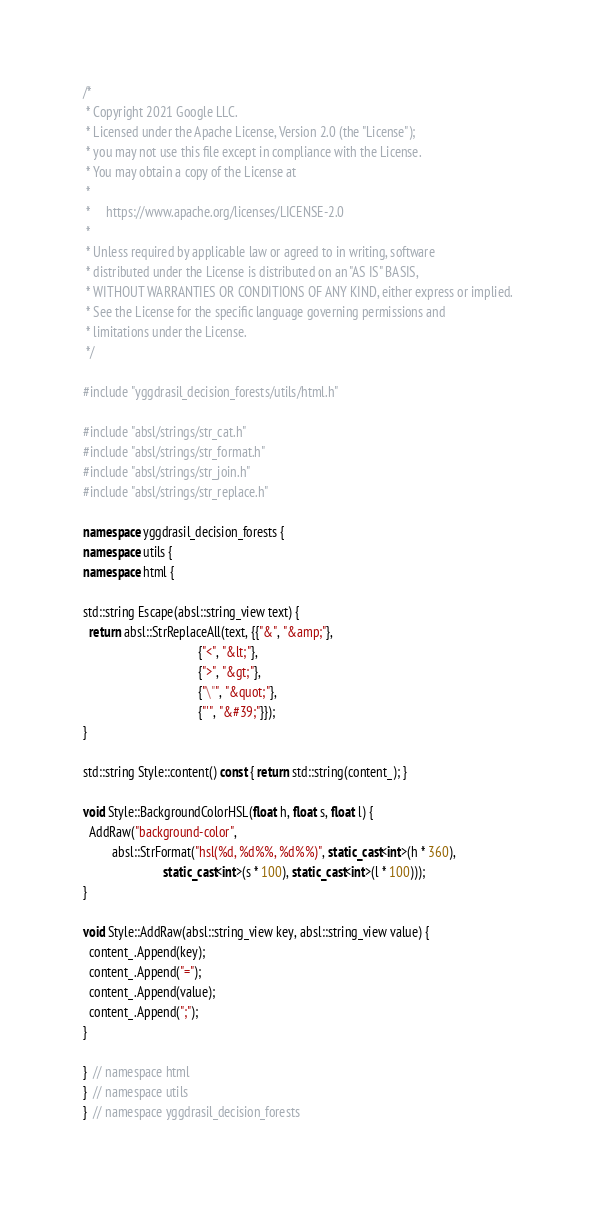Convert code to text. <code><loc_0><loc_0><loc_500><loc_500><_C++_>/*
 * Copyright 2021 Google LLC.
 * Licensed under the Apache License, Version 2.0 (the "License");
 * you may not use this file except in compliance with the License.
 * You may obtain a copy of the License at
 *
 *     https://www.apache.org/licenses/LICENSE-2.0
 *
 * Unless required by applicable law or agreed to in writing, software
 * distributed under the License is distributed on an "AS IS" BASIS,
 * WITHOUT WARRANTIES OR CONDITIONS OF ANY KIND, either express or implied.
 * See the License for the specific language governing permissions and
 * limitations under the License.
 */

#include "yggdrasil_decision_forests/utils/html.h"

#include "absl/strings/str_cat.h"
#include "absl/strings/str_format.h"
#include "absl/strings/str_join.h"
#include "absl/strings/str_replace.h"

namespace yggdrasil_decision_forests {
namespace utils {
namespace html {

std::string Escape(absl::string_view text) {
  return absl::StrReplaceAll(text, {{"&", "&amp;"},
                                    {"<", "&lt;"},
                                    {">", "&gt;"},
                                    {"\"", "&quot;"},
                                    {"'", "&#39;"}});
}

std::string Style::content() const { return std::string(content_); }

void Style::BackgroundColorHSL(float h, float s, float l) {
  AddRaw("background-color",
         absl::StrFormat("hsl(%d, %d%%, %d%%)", static_cast<int>(h * 360),
                         static_cast<int>(s * 100), static_cast<int>(l * 100)));
}

void Style::AddRaw(absl::string_view key, absl::string_view value) {
  content_.Append(key);
  content_.Append("=");
  content_.Append(value);
  content_.Append(";");
}

}  // namespace html
}  // namespace utils
}  // namespace yggdrasil_decision_forests
</code> 